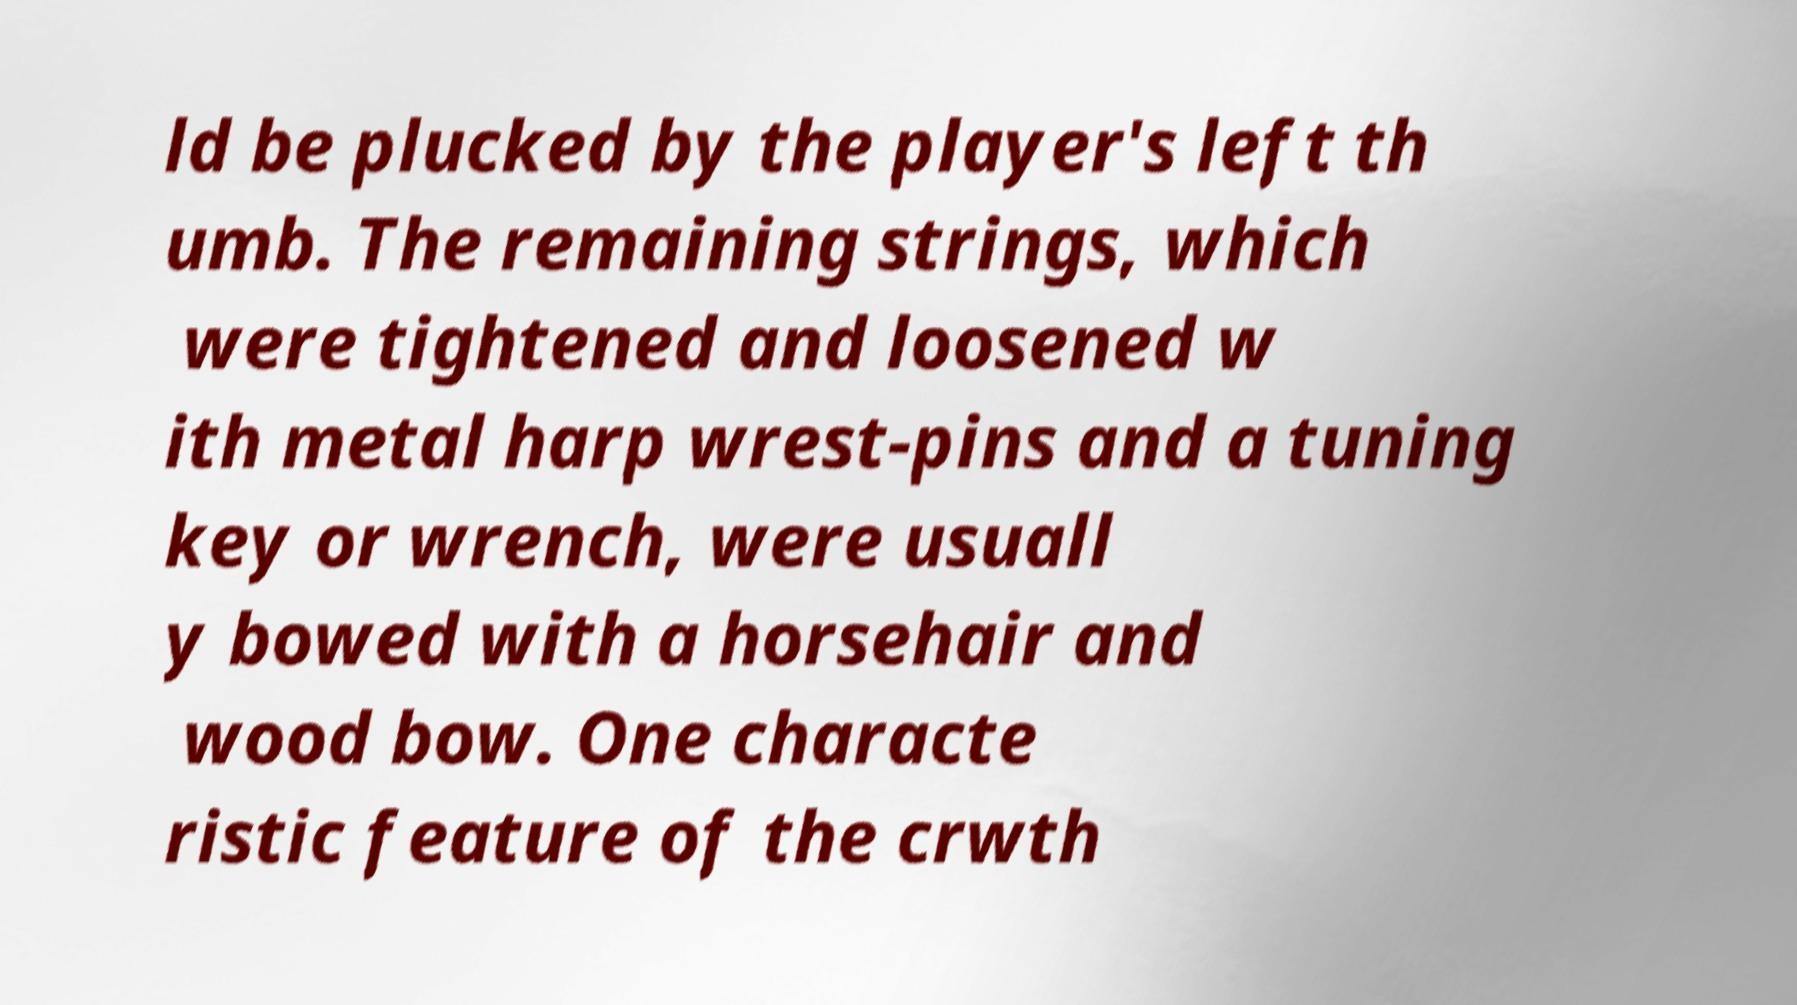There's text embedded in this image that I need extracted. Can you transcribe it verbatim? ld be plucked by the player's left th umb. The remaining strings, which were tightened and loosened w ith metal harp wrest-pins and a tuning key or wrench, were usuall y bowed with a horsehair and wood bow. One characte ristic feature of the crwth 